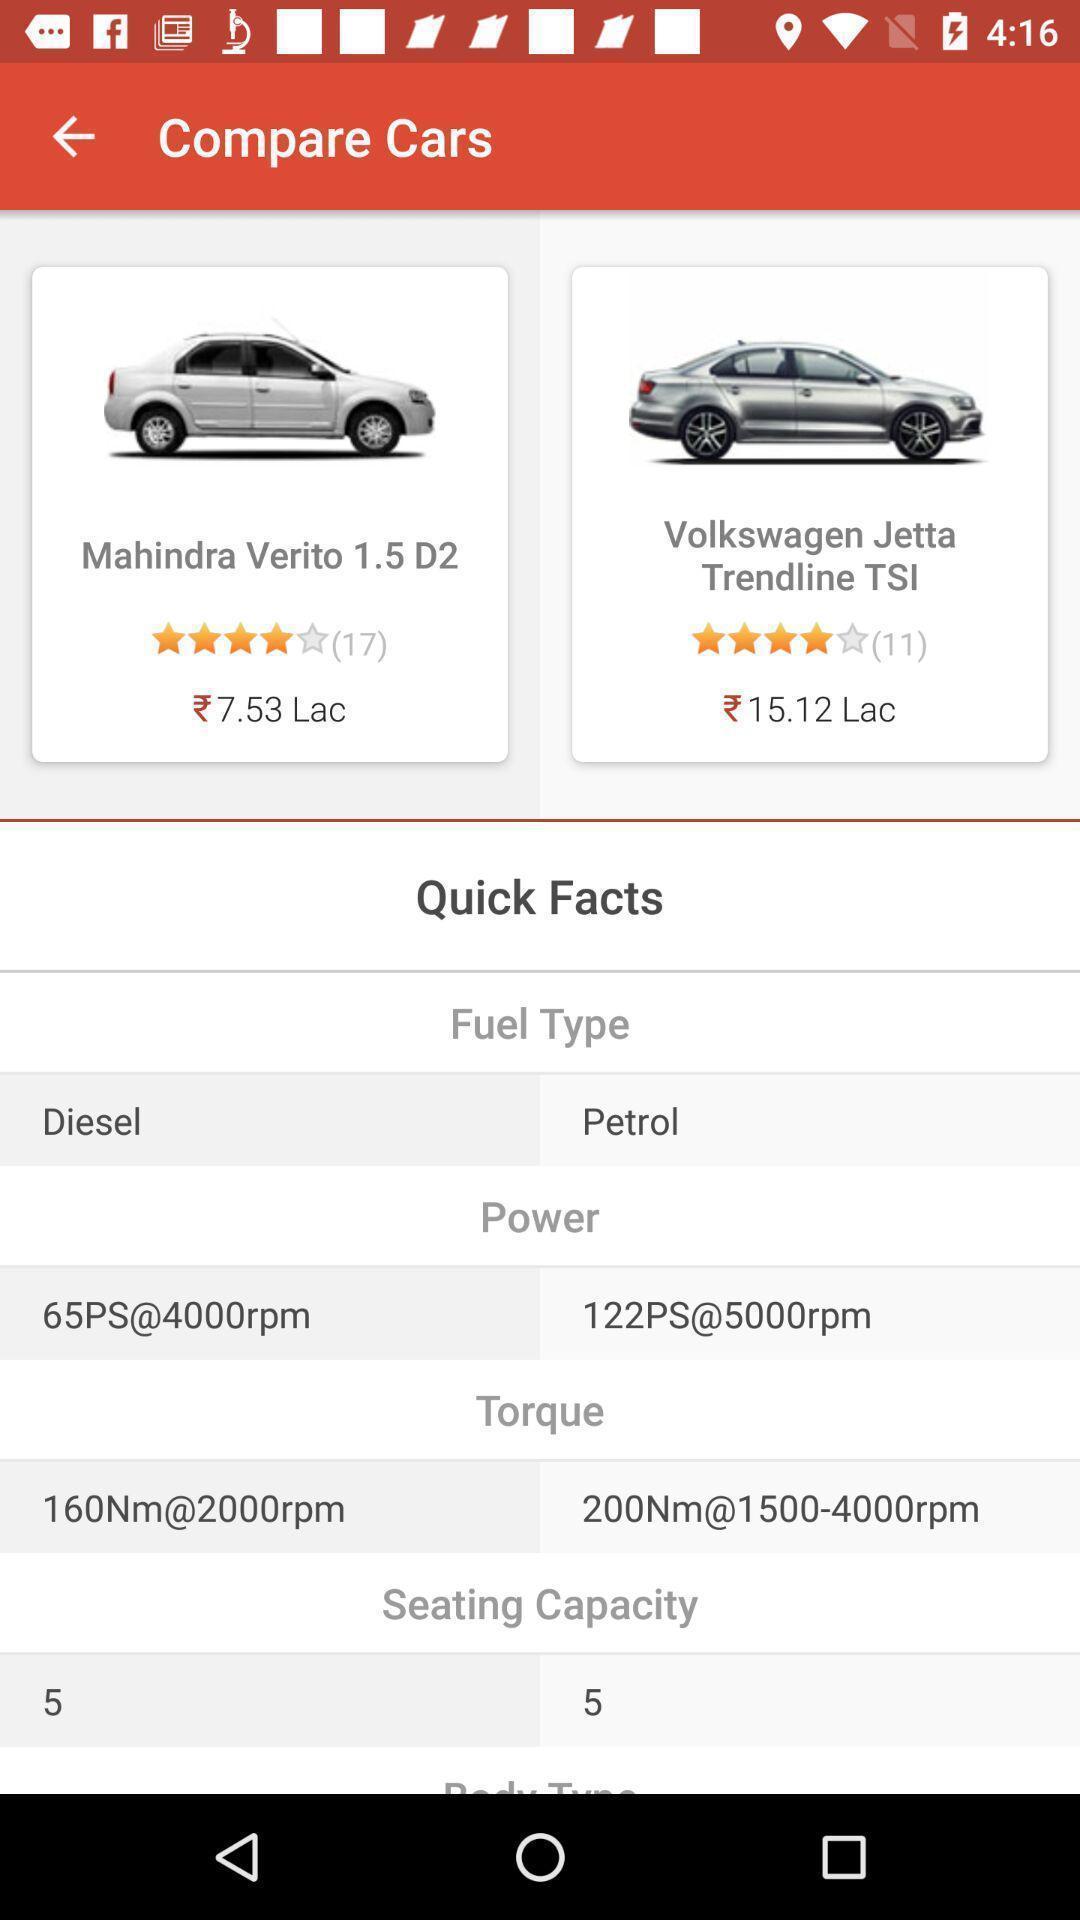Provide a textual representation of this image. Screen shows to compare cars. 